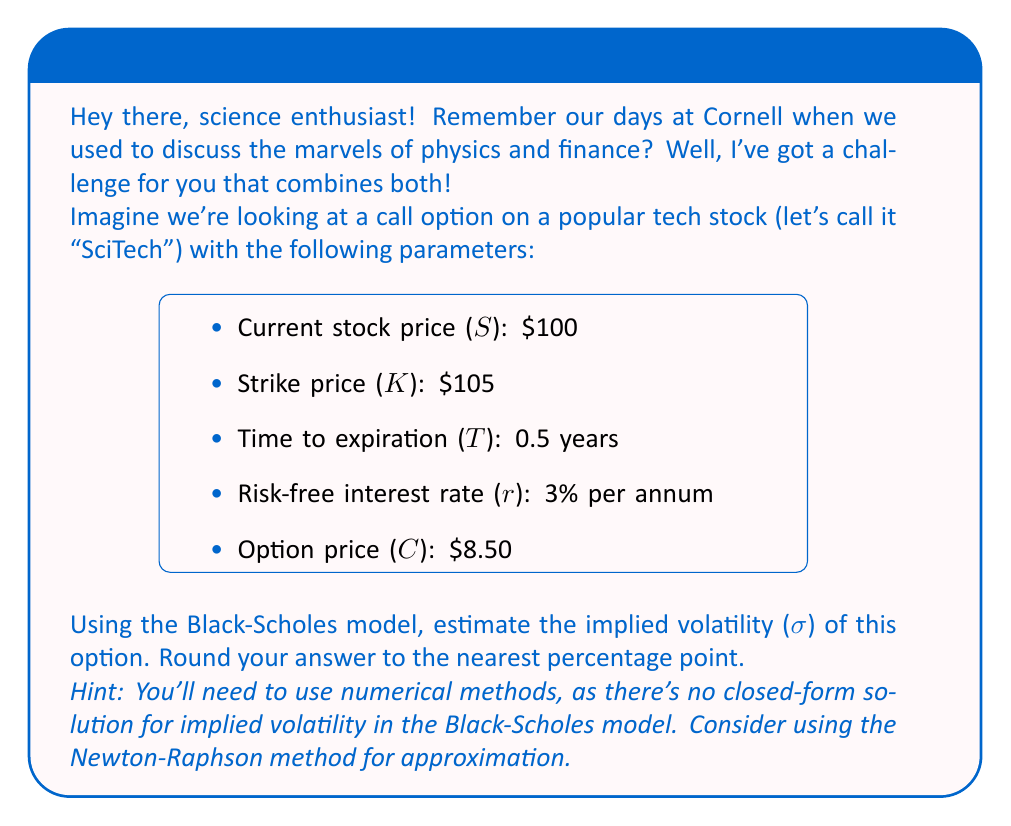Show me your answer to this math problem. Alright, let's break this down step-by-step using our knowledge of the Black-Scholes model and numerical methods:

1) The Black-Scholes formula for a call option is:

   $$C = SN(d_1) - Ke^{-rT}N(d_2)$$

   where:
   $$d_1 = \frac{\ln(S/K) + (r + \sigma^2/2)T}{\sigma\sqrt{T}}$$
   $$d_2 = d_1 - \sigma\sqrt{T}$$

2) We know all parameters except σ (volatility). We need to find σ such that the calculated C matches the observed option price of $8.50.

3) We'll use the Newton-Raphson method to approximate σ:

   $$\sigma_{n+1} = \sigma_n - \frac{C(\sigma_n) - C_{market}}{vega(\sigma_n)}$$

   where C(σ_n) is the Black-Scholes price at the current σ estimate, and vega is the derivative of C with respect to σ.

4) Let's start with an initial guess of σ = 30% (0.30).

5) We'll implement this in a programming language (e.g., Python), but here's the general process:

   a) Calculate C(σ_n) using the Black-Scholes formula
   b) Calculate vega(σ_n) = S√T * N'(d_1)
   c) Update σ using the Newton-Raphson formula
   d) Repeat until |C(σ_n) - C_market| < ε (where ε is a small tolerance, e.g., 0.0001)

6) After several iterations, we converge to σ ≈ 0.3146 or 31.46%

7) Rounding to the nearest percentage point gives us 31%.

This implied volatility of 31% represents the market's expectation of the future volatility of SciTech's stock over the life of the option, based on the current option price.
Answer: 31% 